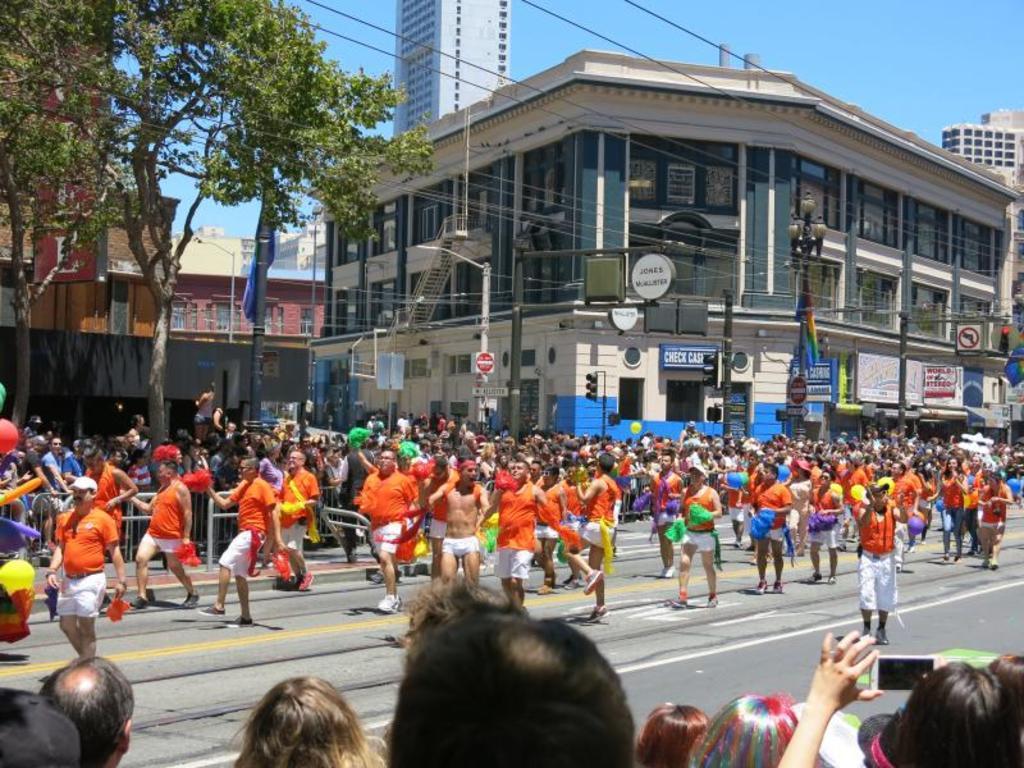Please provide a concise description of this image. This is the picture of a city. In this image there are group of people walking on the road and there are group of people standing behind the railing. At the back there are buildings, trees and poles and there are boards and wires on the poles. At the top there is sky. At the bottom there is a road. In the foreground there are group of people. 